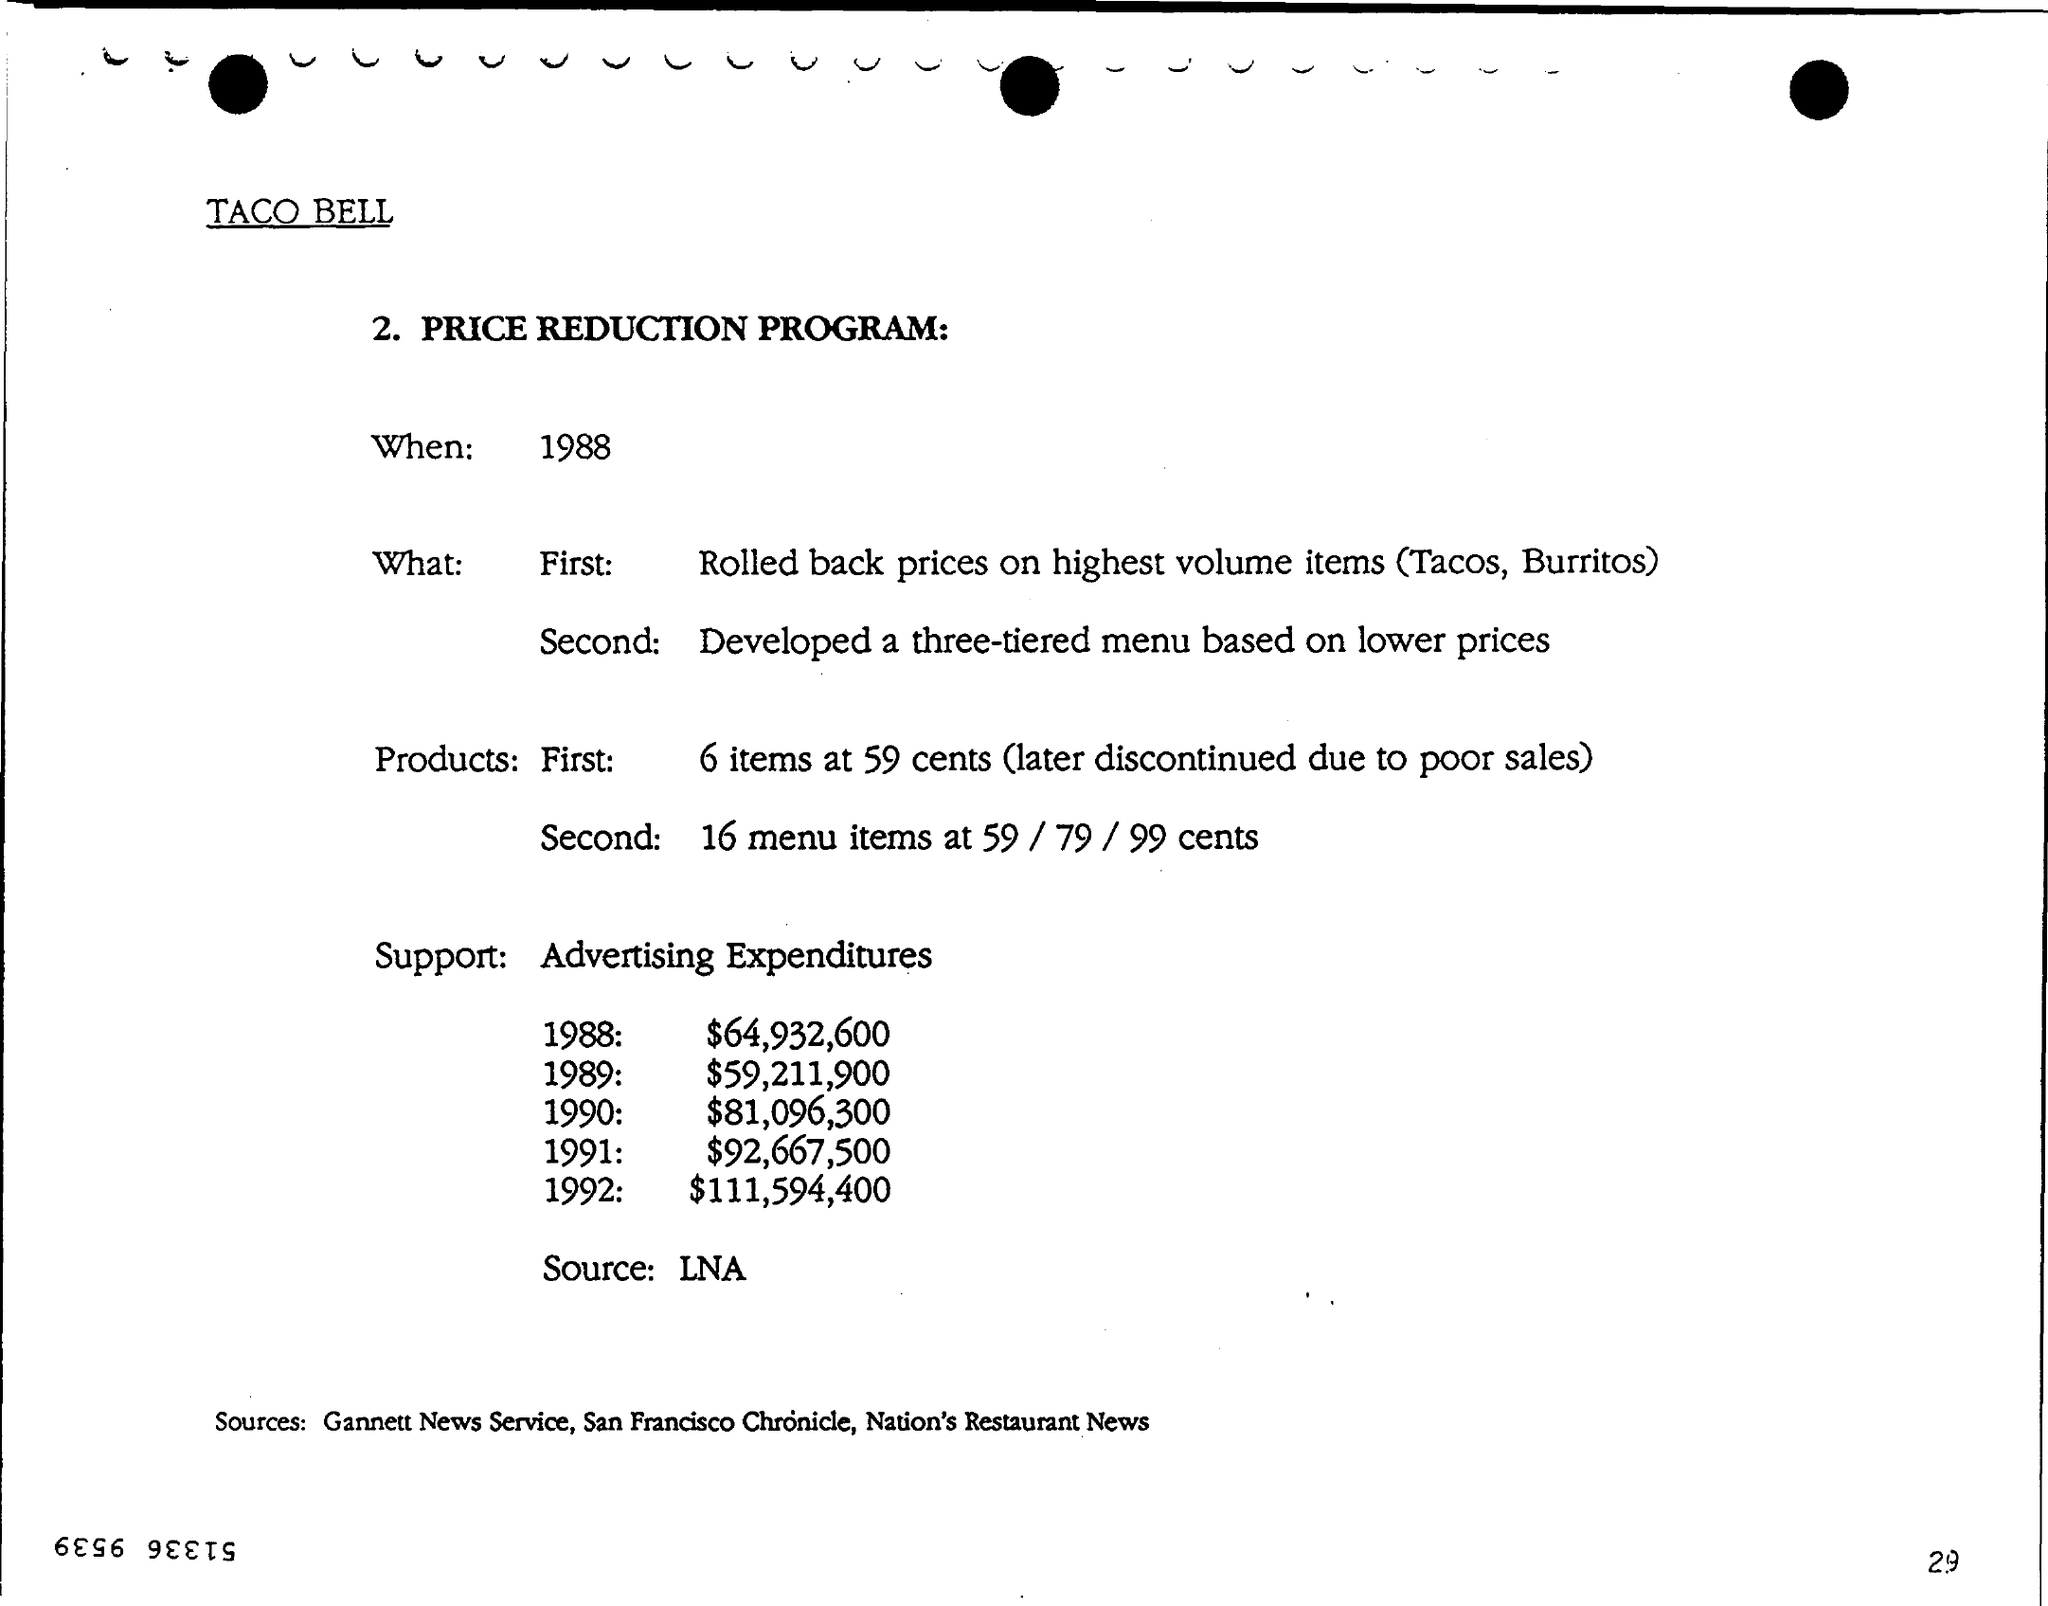What does the advertising expenditure data from 1988 to 1992 indicate about Taco Bell's marketing strategy for the Price Reduction Program? The data shows a substantial and consistent increase in advertising expenditures by Taco Bell, from $64,932,600 in 1988 to $111,594,400 in 1992. This suggests that Taco Bell was heavily investing in marketing to promote their Price Reduction Program, likely aiming to attract customers through the visibility of lower-priced menu options and to emphasize the value offered by the brand during this period. 